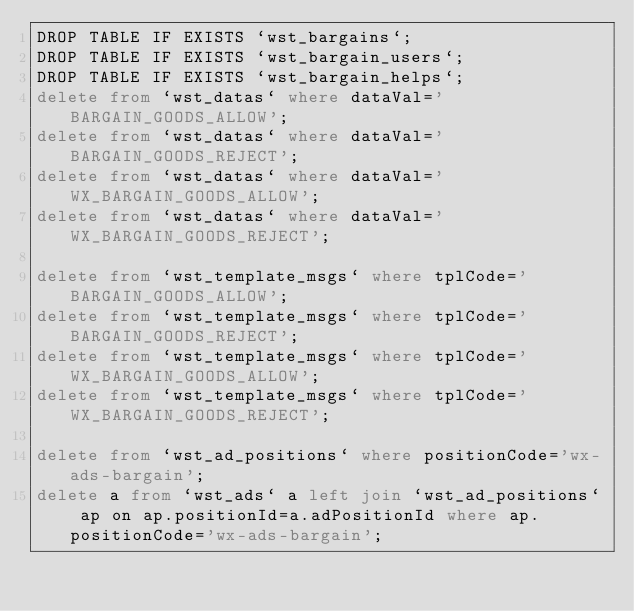Convert code to text. <code><loc_0><loc_0><loc_500><loc_500><_SQL_>DROP TABLE IF EXISTS `wst_bargains`;
DROP TABLE IF EXISTS `wst_bargain_users`;
DROP TABLE IF EXISTS `wst_bargain_helps`;
delete from `wst_datas` where dataVal='BARGAIN_GOODS_ALLOW';
delete from `wst_datas` where dataVal='BARGAIN_GOODS_REJECT';
delete from `wst_datas` where dataVal='WX_BARGAIN_GOODS_ALLOW';
delete from `wst_datas` where dataVal='WX_BARGAIN_GOODS_REJECT';

delete from `wst_template_msgs` where tplCode='BARGAIN_GOODS_ALLOW';
delete from `wst_template_msgs` where tplCode='BARGAIN_GOODS_REJECT';
delete from `wst_template_msgs` where tplCode='WX_BARGAIN_GOODS_ALLOW';
delete from `wst_template_msgs` where tplCode='WX_BARGAIN_GOODS_REJECT';

delete from `wst_ad_positions` where positionCode='wx-ads-bargain';
delete a from `wst_ads` a left join `wst_ad_positions` ap on ap.positionId=a.adPositionId where ap.positionCode='wx-ads-bargain';

</code> 